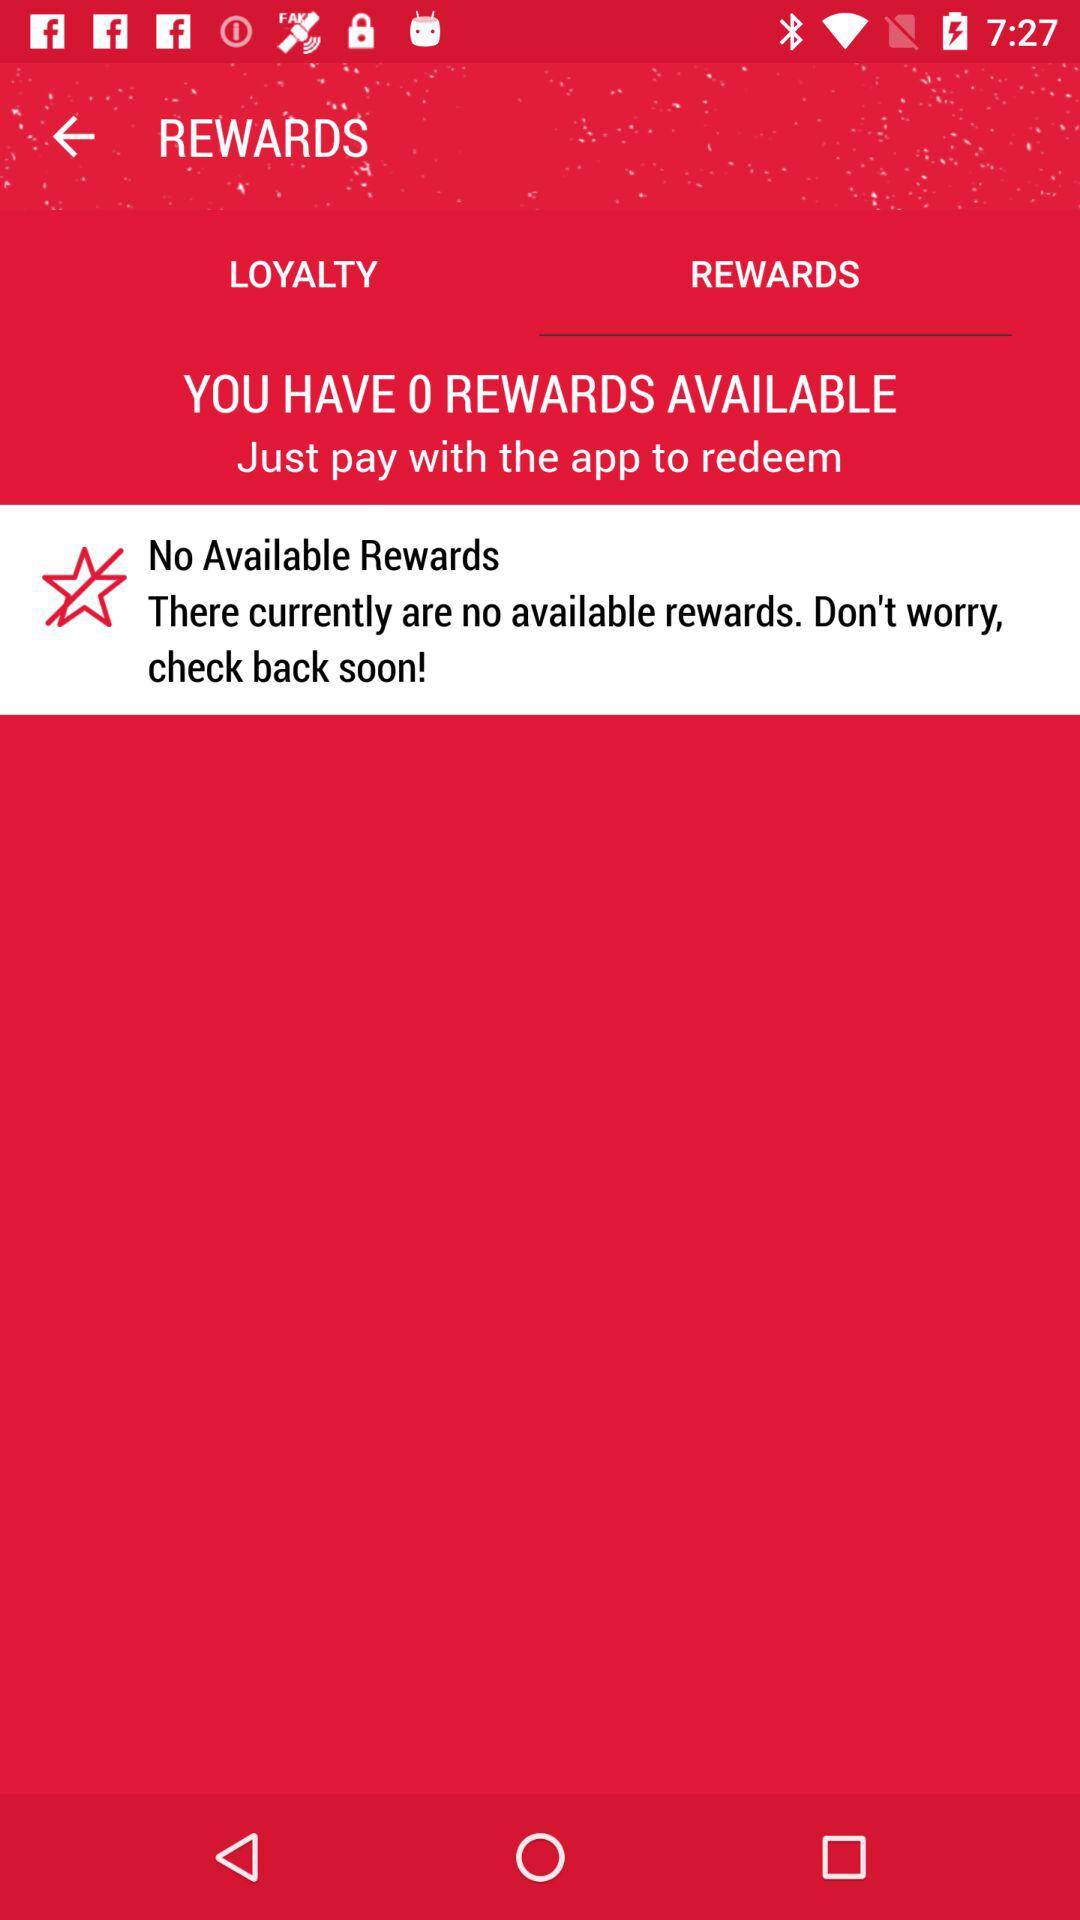Which option has been selected? The selected option is "REWARDS". 